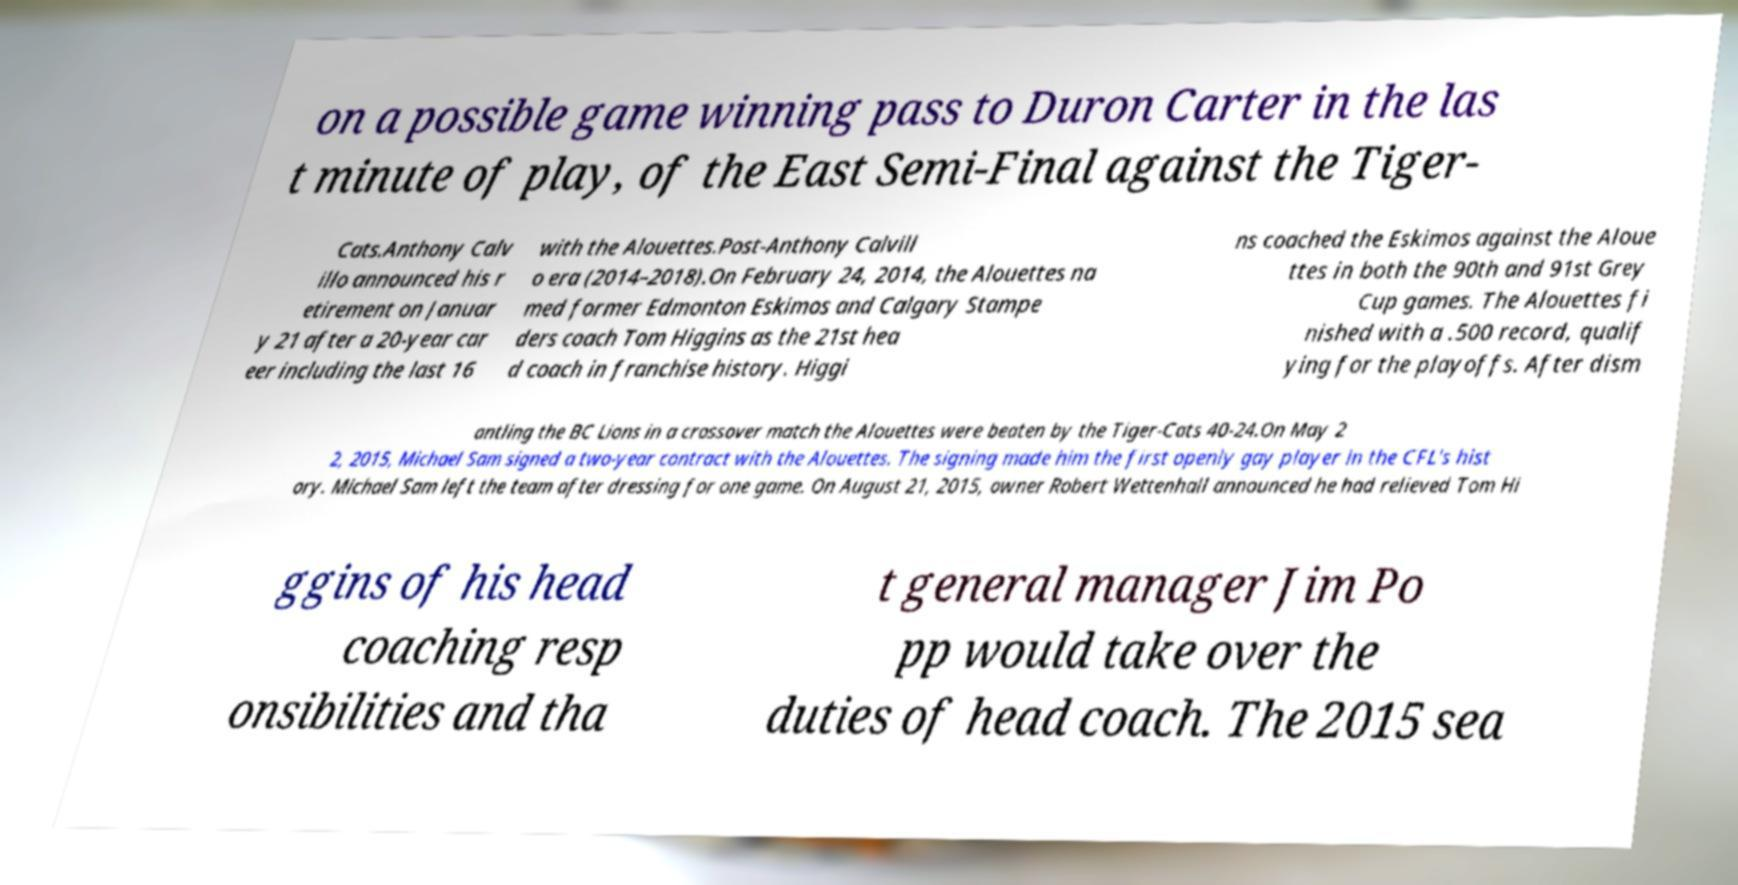Can you read and provide the text displayed in the image?This photo seems to have some interesting text. Can you extract and type it out for me? on a possible game winning pass to Duron Carter in the las t minute of play, of the East Semi-Final against the Tiger- Cats.Anthony Calv illo announced his r etirement on Januar y 21 after a 20-year car eer including the last 16 with the Alouettes.Post-Anthony Calvill o era (2014–2018).On February 24, 2014, the Alouettes na med former Edmonton Eskimos and Calgary Stampe ders coach Tom Higgins as the 21st hea d coach in franchise history. Higgi ns coached the Eskimos against the Aloue ttes in both the 90th and 91st Grey Cup games. The Alouettes fi nished with a .500 record, qualif ying for the playoffs. After dism antling the BC Lions in a crossover match the Alouettes were beaten by the Tiger-Cats 40-24.On May 2 2, 2015, Michael Sam signed a two-year contract with the Alouettes. The signing made him the first openly gay player in the CFL's hist ory. Michael Sam left the team after dressing for one game. On August 21, 2015, owner Robert Wettenhall announced he had relieved Tom Hi ggins of his head coaching resp onsibilities and tha t general manager Jim Po pp would take over the duties of head coach. The 2015 sea 